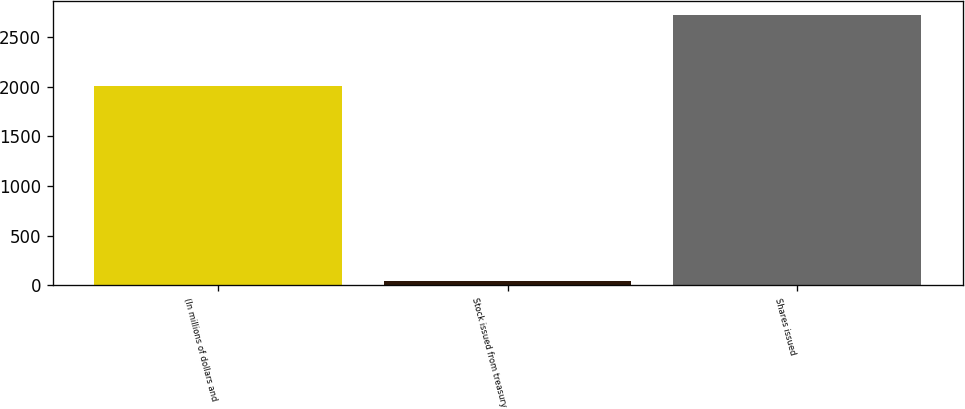Convert chart to OTSL. <chart><loc_0><loc_0><loc_500><loc_500><bar_chart><fcel>(In millions of dollars and<fcel>Stock issued from treasury<fcel>Shares issued<nl><fcel>2007<fcel>47<fcel>2723<nl></chart> 